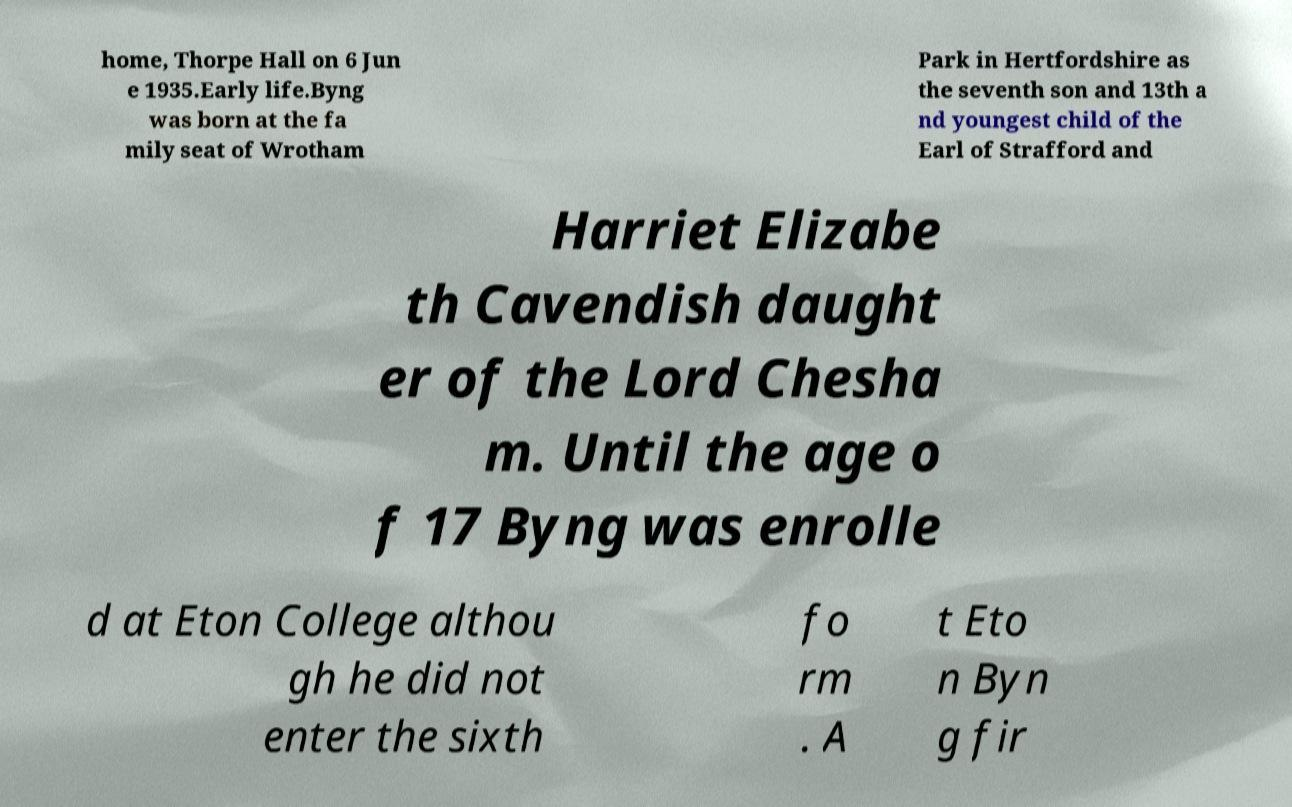What messages or text are displayed in this image? I need them in a readable, typed format. home, Thorpe Hall on 6 Jun e 1935.Early life.Byng was born at the fa mily seat of Wrotham Park in Hertfordshire as the seventh son and 13th a nd youngest child of the Earl of Strafford and Harriet Elizabe th Cavendish daught er of the Lord Chesha m. Until the age o f 17 Byng was enrolle d at Eton College althou gh he did not enter the sixth fo rm . A t Eto n Byn g fir 